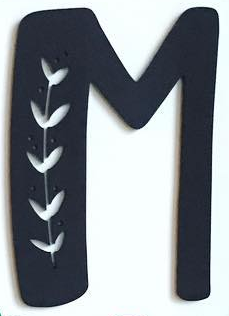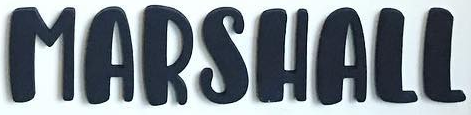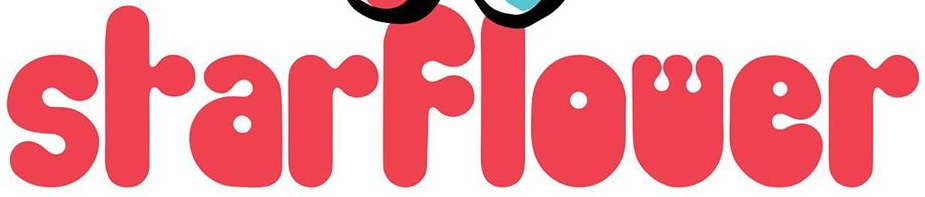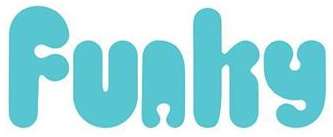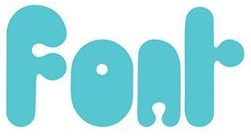Read the text from these images in sequence, separated by a semicolon. M; MARSHALL; SrarFlower; Funhy; Fonr 